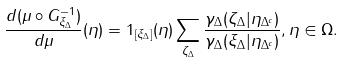<formula> <loc_0><loc_0><loc_500><loc_500>\frac { d ( \mu \circ G _ { \xi _ { \Delta } } ^ { - 1 } ) } { d \mu } ( \eta ) = 1 _ { [ \xi _ { \Delta } ] } ( \eta ) \sum _ { \zeta _ { \Delta } } \frac { \gamma _ { \Delta } ( \zeta _ { \Delta } | \eta _ { \Delta ^ { c } } ) } { \gamma _ { \Delta } ( \xi _ { \Delta } | \eta _ { \Delta ^ { c } } ) } , \eta \in \Omega .</formula> 